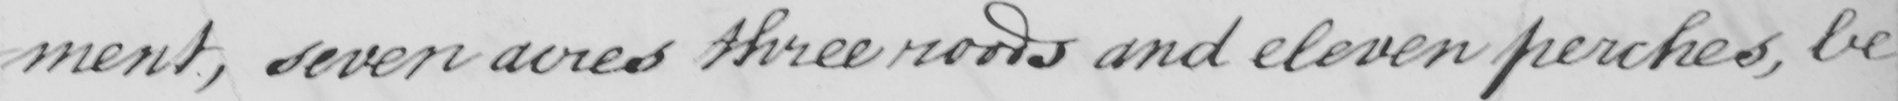Can you tell me what this handwritten text says? -ment , seven acres three roods and eleven perches , be 